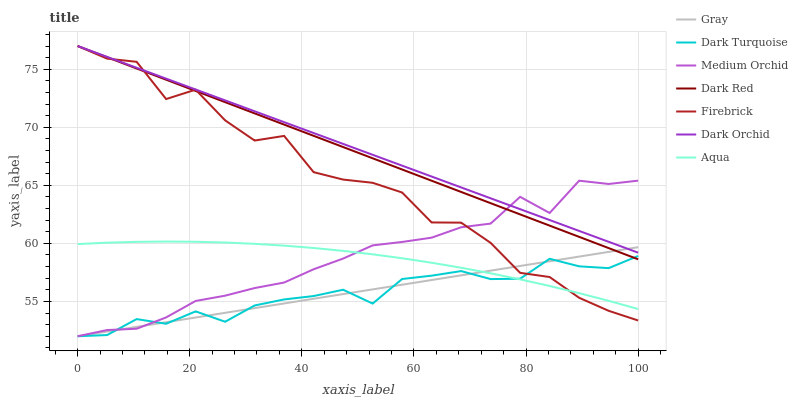Does Dark Turquoise have the minimum area under the curve?
Answer yes or no. Yes. Does Dark Orchid have the maximum area under the curve?
Answer yes or no. Yes. Does Dark Red have the minimum area under the curve?
Answer yes or no. No. Does Dark Red have the maximum area under the curve?
Answer yes or no. No. Is Gray the smoothest?
Answer yes or no. Yes. Is Firebrick the roughest?
Answer yes or no. Yes. Is Dark Red the smoothest?
Answer yes or no. No. Is Dark Red the roughest?
Answer yes or no. No. Does Dark Red have the lowest value?
Answer yes or no. No. Does Dark Orchid have the highest value?
Answer yes or no. Yes. Does Medium Orchid have the highest value?
Answer yes or no. No. Is Dark Turquoise less than Dark Orchid?
Answer yes or no. Yes. Is Dark Red greater than Aqua?
Answer yes or no. Yes. Does Firebrick intersect Dark Red?
Answer yes or no. Yes. Is Firebrick less than Dark Red?
Answer yes or no. No. Is Firebrick greater than Dark Red?
Answer yes or no. No. Does Dark Turquoise intersect Dark Orchid?
Answer yes or no. No. 